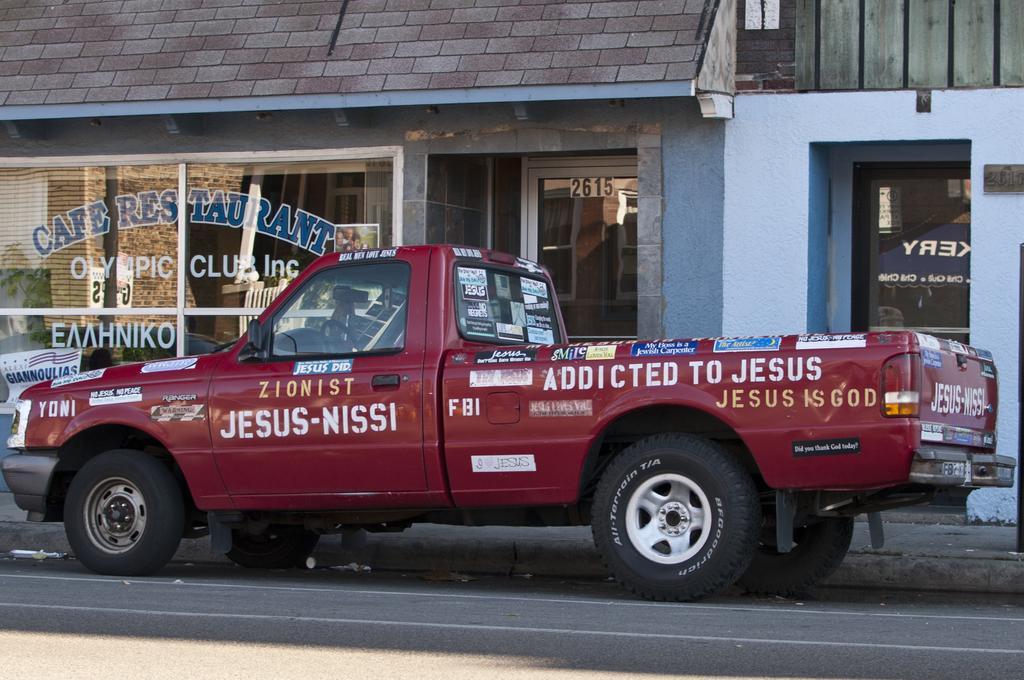Can you describe this image briefly? In this image we can see a vehicle on the road. In the background there is a house, door, texts on the glass, roof and other objects. 